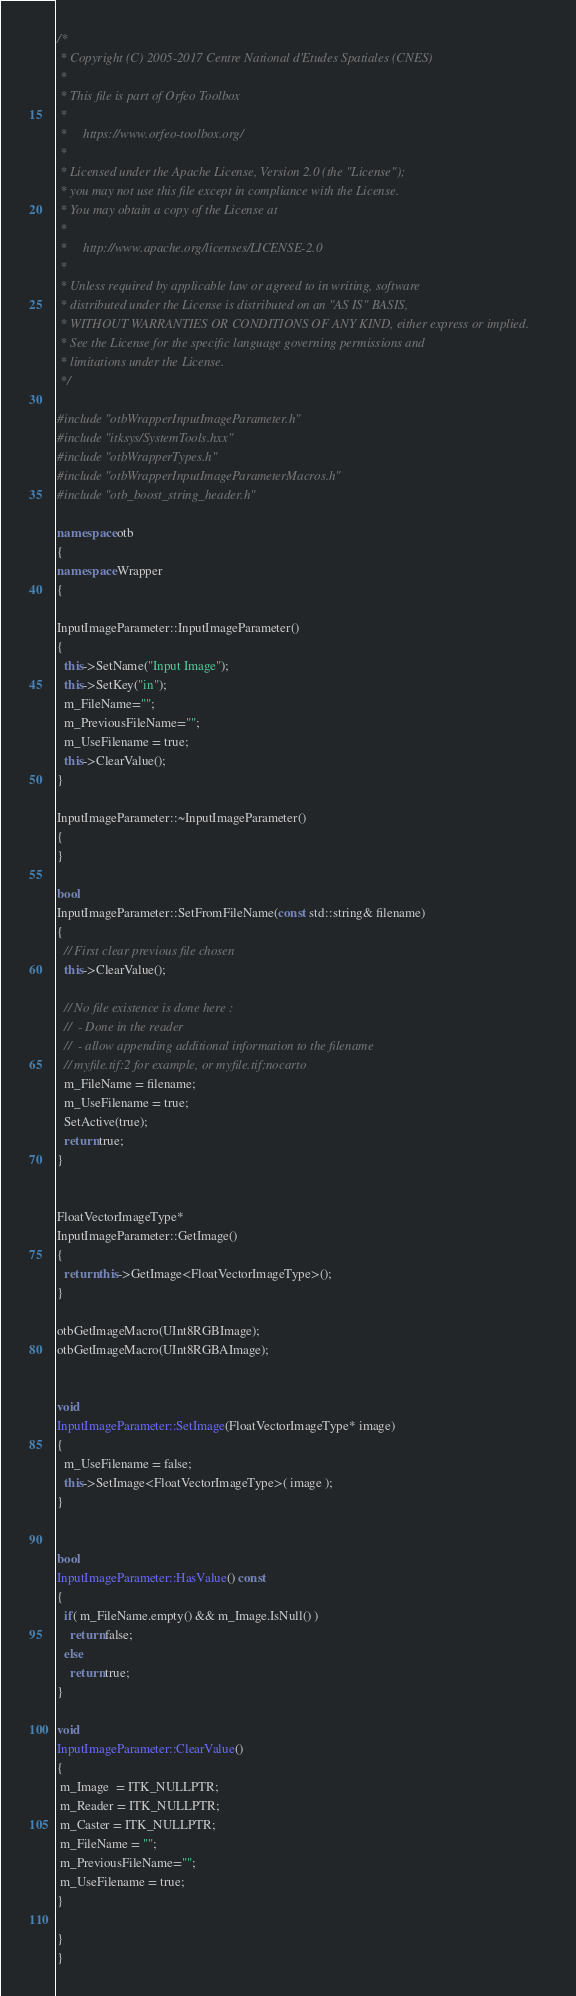<code> <loc_0><loc_0><loc_500><loc_500><_C++_>/*
 * Copyright (C) 2005-2017 Centre National d'Etudes Spatiales (CNES)
 *
 * This file is part of Orfeo Toolbox
 *
 *     https://www.orfeo-toolbox.org/
 *
 * Licensed under the Apache License, Version 2.0 (the "License");
 * you may not use this file except in compliance with the License.
 * You may obtain a copy of the License at
 *
 *     http://www.apache.org/licenses/LICENSE-2.0
 *
 * Unless required by applicable law or agreed to in writing, software
 * distributed under the License is distributed on an "AS IS" BASIS,
 * WITHOUT WARRANTIES OR CONDITIONS OF ANY KIND, either express or implied.
 * See the License for the specific language governing permissions and
 * limitations under the License.
 */

#include "otbWrapperInputImageParameter.h"
#include "itksys/SystemTools.hxx"
#include "otbWrapperTypes.h"
#include "otbWrapperInputImageParameterMacros.h"
#include "otb_boost_string_header.h"

namespace otb
{
namespace Wrapper
{

InputImageParameter::InputImageParameter()
{
  this->SetName("Input Image");
  this->SetKey("in");
  m_FileName="";
  m_PreviousFileName="";
  m_UseFilename = true;
  this->ClearValue();
}

InputImageParameter::~InputImageParameter()
{
}

bool
InputImageParameter::SetFromFileName(const std::string& filename)
{
  // First clear previous file chosen
  this->ClearValue();

  // No file existence is done here :
  //  - Done in the reader
  //  - allow appending additional information to the filename
  // myfile.tif:2 for example, or myfile.tif:nocarto
  m_FileName = filename;
  m_UseFilename = true;
  SetActive(true);
  return true;
}


FloatVectorImageType*
InputImageParameter::GetImage()
{
  return this->GetImage<FloatVectorImageType>();
}

otbGetImageMacro(UInt8RGBImage);
otbGetImageMacro(UInt8RGBAImage);


void
InputImageParameter::SetImage(FloatVectorImageType* image)
{
  m_UseFilename = false;
  this->SetImage<FloatVectorImageType>( image );
}


bool
InputImageParameter::HasValue() const
{
  if( m_FileName.empty() && m_Image.IsNull() )
    return false;
  else
    return true;
}

void
InputImageParameter::ClearValue()
{
 m_Image  = ITK_NULLPTR;
 m_Reader = ITK_NULLPTR;
 m_Caster = ITK_NULLPTR;
 m_FileName = "";
 m_PreviousFileName="";
 m_UseFilename = true;
}

}
}
</code> 